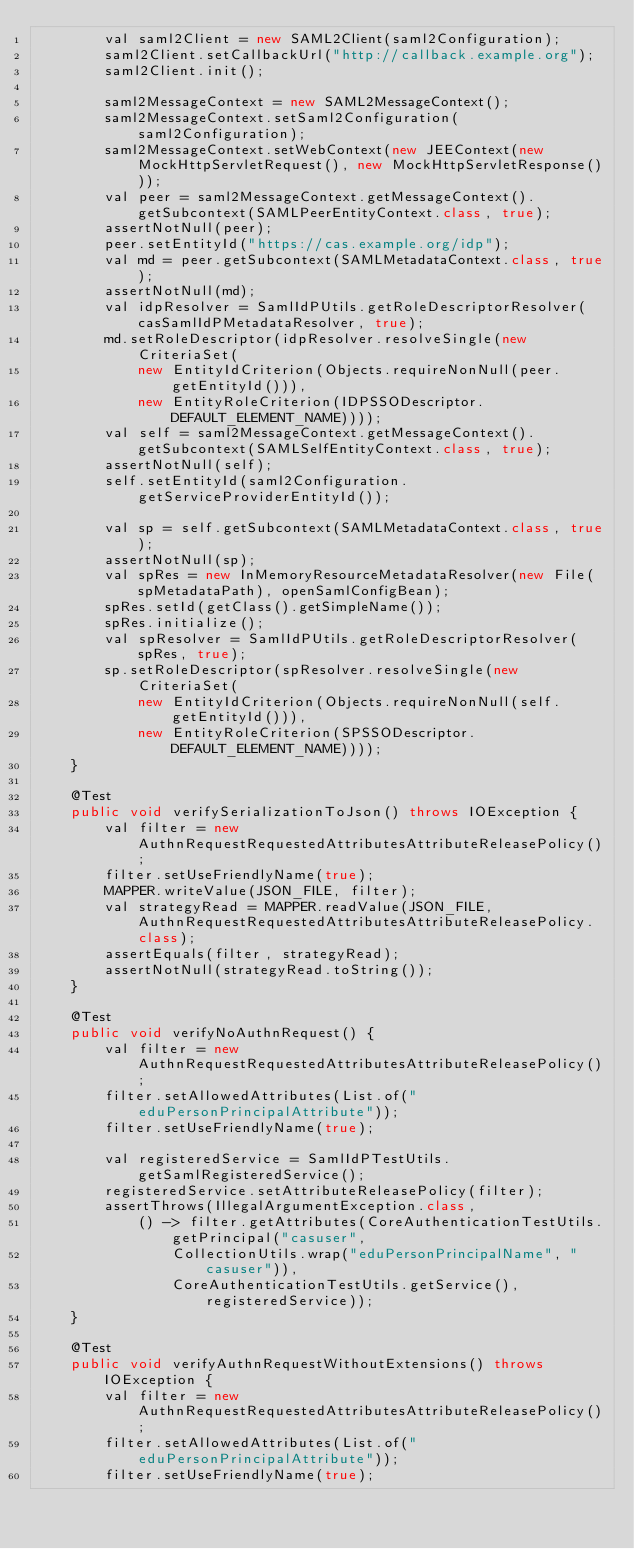<code> <loc_0><loc_0><loc_500><loc_500><_Java_>        val saml2Client = new SAML2Client(saml2Configuration);
        saml2Client.setCallbackUrl("http://callback.example.org");
        saml2Client.init();

        saml2MessageContext = new SAML2MessageContext();
        saml2MessageContext.setSaml2Configuration(saml2Configuration);
        saml2MessageContext.setWebContext(new JEEContext(new MockHttpServletRequest(), new MockHttpServletResponse()));
        val peer = saml2MessageContext.getMessageContext().getSubcontext(SAMLPeerEntityContext.class, true);
        assertNotNull(peer);
        peer.setEntityId("https://cas.example.org/idp");
        val md = peer.getSubcontext(SAMLMetadataContext.class, true);
        assertNotNull(md);
        val idpResolver = SamlIdPUtils.getRoleDescriptorResolver(casSamlIdPMetadataResolver, true);
        md.setRoleDescriptor(idpResolver.resolveSingle(new CriteriaSet(
            new EntityIdCriterion(Objects.requireNonNull(peer.getEntityId())),
            new EntityRoleCriterion(IDPSSODescriptor.DEFAULT_ELEMENT_NAME))));
        val self = saml2MessageContext.getMessageContext().getSubcontext(SAMLSelfEntityContext.class, true);
        assertNotNull(self);
        self.setEntityId(saml2Configuration.getServiceProviderEntityId());

        val sp = self.getSubcontext(SAMLMetadataContext.class, true);
        assertNotNull(sp);
        val spRes = new InMemoryResourceMetadataResolver(new File(spMetadataPath), openSamlConfigBean);
        spRes.setId(getClass().getSimpleName());
        spRes.initialize();
        val spResolver = SamlIdPUtils.getRoleDescriptorResolver(spRes, true);
        sp.setRoleDescriptor(spResolver.resolveSingle(new CriteriaSet(
            new EntityIdCriterion(Objects.requireNonNull(self.getEntityId())),
            new EntityRoleCriterion(SPSSODescriptor.DEFAULT_ELEMENT_NAME))));
    }

    @Test
    public void verifySerializationToJson() throws IOException {
        val filter = new AuthnRequestRequestedAttributesAttributeReleasePolicy();
        filter.setUseFriendlyName(true);
        MAPPER.writeValue(JSON_FILE, filter);
        val strategyRead = MAPPER.readValue(JSON_FILE, AuthnRequestRequestedAttributesAttributeReleasePolicy.class);
        assertEquals(filter, strategyRead);
        assertNotNull(strategyRead.toString());
    }

    @Test
    public void verifyNoAuthnRequest() {
        val filter = new AuthnRequestRequestedAttributesAttributeReleasePolicy();
        filter.setAllowedAttributes(List.of("eduPersonPrincipalAttribute"));
        filter.setUseFriendlyName(true);

        val registeredService = SamlIdPTestUtils.getSamlRegisteredService();
        registeredService.setAttributeReleasePolicy(filter);
        assertThrows(IllegalArgumentException.class,
            () -> filter.getAttributes(CoreAuthenticationTestUtils.getPrincipal("casuser",
                CollectionUtils.wrap("eduPersonPrincipalName", "casuser")),
                CoreAuthenticationTestUtils.getService(), registeredService));
    }

    @Test
    public void verifyAuthnRequestWithoutExtensions() throws IOException {
        val filter = new AuthnRequestRequestedAttributesAttributeReleasePolicy();
        filter.setAllowedAttributes(List.of("eduPersonPrincipalAttribute"));
        filter.setUseFriendlyName(true);
</code> 